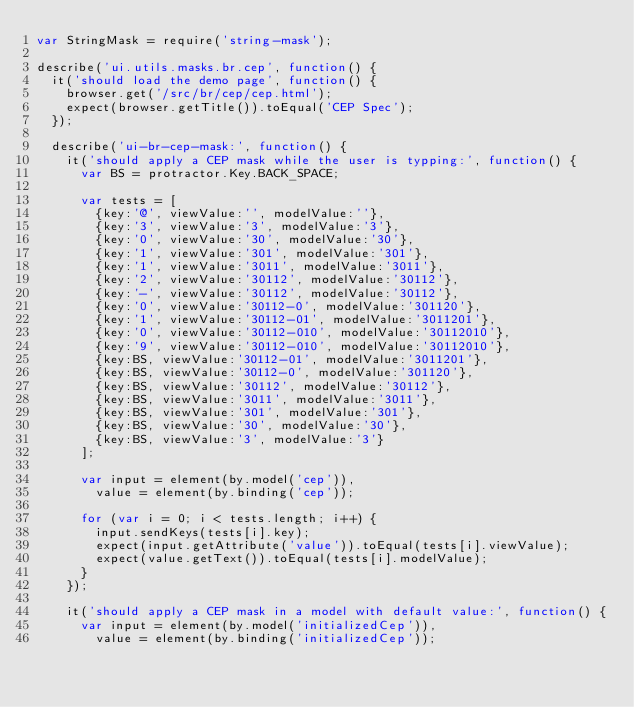Convert code to text. <code><loc_0><loc_0><loc_500><loc_500><_JavaScript_>var StringMask = require('string-mask');

describe('ui.utils.masks.br.cep', function() {
	it('should load the demo page', function() {
		browser.get('/src/br/cep/cep.html');
		expect(browser.getTitle()).toEqual('CEP Spec');
	});

	describe('ui-br-cep-mask:', function() {
		it('should apply a CEP mask while the user is typping:', function() {
			var BS = protractor.Key.BACK_SPACE;

			var tests = [
				{key:'@', viewValue:'', modelValue:''},
				{key:'3', viewValue:'3', modelValue:'3'},
				{key:'0', viewValue:'30', modelValue:'30'},
				{key:'1', viewValue:'301', modelValue:'301'},
				{key:'1', viewValue:'3011', modelValue:'3011'},
				{key:'2', viewValue:'30112', modelValue:'30112'},
				{key:'-', viewValue:'30112', modelValue:'30112'},
				{key:'0', viewValue:'30112-0', modelValue:'301120'},
				{key:'1', viewValue:'30112-01', modelValue:'3011201'},
				{key:'0', viewValue:'30112-010', modelValue:'30112010'},
				{key:'9', viewValue:'30112-010', modelValue:'30112010'},
				{key:BS, viewValue:'30112-01', modelValue:'3011201'},
				{key:BS, viewValue:'30112-0', modelValue:'301120'},
				{key:BS, viewValue:'30112', modelValue:'30112'},
				{key:BS, viewValue:'3011', modelValue:'3011'},
				{key:BS, viewValue:'301', modelValue:'301'},
				{key:BS, viewValue:'30', modelValue:'30'},
				{key:BS, viewValue:'3', modelValue:'3'}
			];

			var input = element(by.model('cep')),
				value = element(by.binding('cep'));

			for (var i = 0; i < tests.length; i++) {
				input.sendKeys(tests[i].key);
				expect(input.getAttribute('value')).toEqual(tests[i].viewValue);
				expect(value.getText()).toEqual(tests[i].modelValue);
			}
		});

		it('should apply a CEP mask in a model with default value:', function() {
			var input = element(by.model('initializedCep')),
				value = element(by.binding('initializedCep'));
</code> 